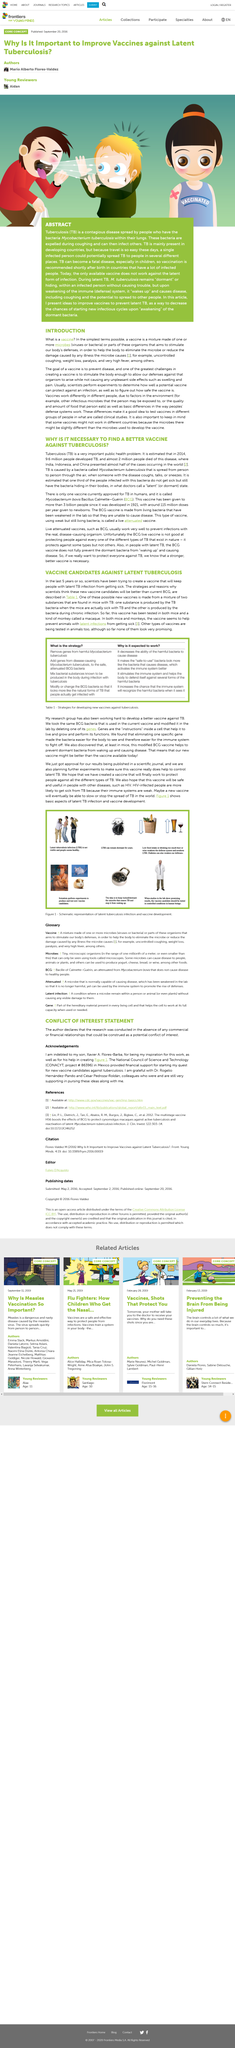List a handful of essential elements in this visual. Genes are a set of instructions found within a cell that instruct the cell on how to function, grow, and maintain its vital processes. In 2014, an estimated 9.6 million people developed tuberculosis, according to estimates. Tuberculosis (TB) is primarily present in developing countries, but due to the ease of travel, it has the potential to be spread by a single infected person to multiple locations. In 2014, an estimated 1.9 million people died of tuberculosis, according to estimates. The acronym 'BCG' represents Bacillus Calmette-Guérin, a type of bacteria commonly used in the prevention and treatment of disease. 